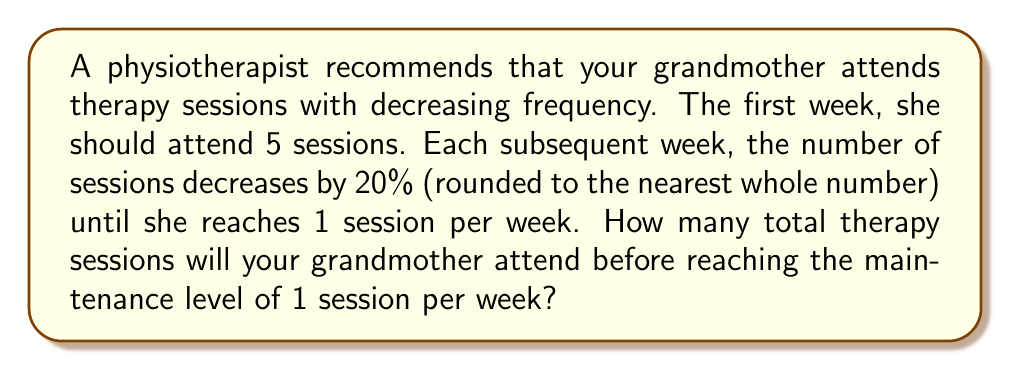Can you solve this math problem? Let's approach this step-by-step:

1) We start with 5 sessions in the first week.
2) Each week, the number of sessions decreases by 20%.

Let's calculate the number of sessions for each week:

Week 1: 5 sessions
Week 2: $5 \times (1 - 0.20) = 4$ sessions (rounded)
Week 3: $4 \times (1 - 0.20) = 3.2 \approx 3$ sessions (rounded)
Week 4: $3 \times (1 - 0.20) = 2.4 \approx 2$ sessions (rounded)
Week 5: $2 \times (1 - 0.20) = 1.6 \approx 2$ sessions (rounded)
Week 6: $2 \times (1 - 0.20) = 1.6 \approx 2$ sessions (rounded)
Week 7: $2 \times (1 - 0.20) = 1.6 \approx 2$ sessions (rounded)
Week 8: $2 \times (1 - 0.20) = 1.6 \approx 2$ sessions (rounded)
Week 9: $2 \times (1 - 0.20) = 1.6 \approx 2$ sessions (rounded)
Week 10: $2 \times (1 - 0.20) = 1.6 \approx 2$ sessions (rounded)
Week 11: $2 \times (1 - 0.20) = 1.6 \approx 2$ sessions (rounded)
Week 12: $2 \times (1 - 0.20) = 1.6 \approx 2$ sessions (rounded)
Week 13: $2 \times (1 - 0.20) = 1.6 \approx 2$ sessions (rounded)
Week 14: $2 \times (1 - 0.20) = 1.6 \approx 2$ sessions (rounded)
Week 15: $2 \times (1 - 0.20) = 1.6 \approx 2$ sessions (rounded)
Week 16: $2 \times (1 - 0.20) = 1.6 \approx 2$ sessions (rounded)
Week 17: $2 \times (1 - 0.20) = 1.6 \approx 2$ sessions (rounded)
Week 18: $2 \times (1 - 0.20) = 1.6 \approx 1$ session (rounded)

The number of sessions reaches 1 in Week 18.

To calculate the total number of sessions, we sum up all sessions from Week 1 to Week 17:

$5 + 4 + 3 + 2 + (2 \times 13) = 14 + 26 = 40$

Therefore, your grandmother will attend a total of 40 therapy sessions before reaching the maintenance level of 1 session per week.
Answer: 40 sessions 